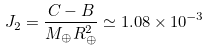Convert formula to latex. <formula><loc_0><loc_0><loc_500><loc_500>J _ { 2 } = { \frac { C - B } { M _ { \oplus } R _ { \oplus } ^ { 2 } } } \simeq 1 . 0 8 \times 1 0 ^ { - 3 }</formula> 